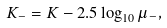<formula> <loc_0><loc_0><loc_500><loc_500>K _ { - } = K - 2 . 5 \log _ { 1 0 } \mu _ { - } ,</formula> 